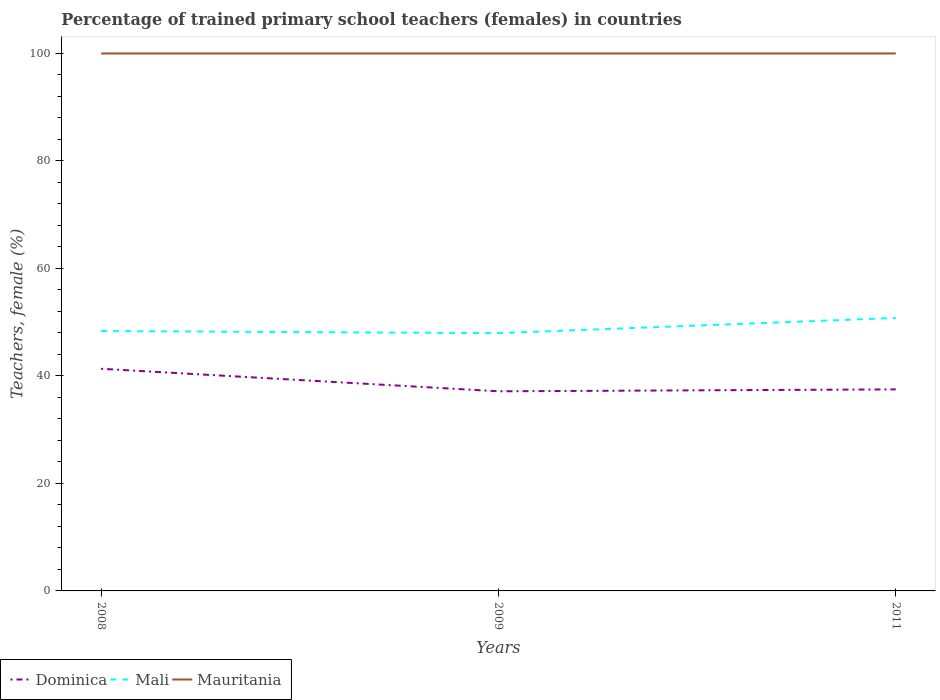Does the line corresponding to Dominica intersect with the line corresponding to Mauritania?
Offer a terse response. No. Across all years, what is the maximum percentage of trained primary school teachers (females) in Dominica?
Make the answer very short. 37.14. In which year was the percentage of trained primary school teachers (females) in Mauritania maximum?
Your answer should be compact. 2008. What is the total percentage of trained primary school teachers (females) in Dominica in the graph?
Provide a short and direct response. 3.83. What is the difference between the highest and the second highest percentage of trained primary school teachers (females) in Dominica?
Keep it short and to the point. 4.19. What is the difference between two consecutive major ticks on the Y-axis?
Keep it short and to the point. 20. Where does the legend appear in the graph?
Your answer should be very brief. Bottom left. How are the legend labels stacked?
Make the answer very short. Horizontal. What is the title of the graph?
Keep it short and to the point. Percentage of trained primary school teachers (females) in countries. Does "France" appear as one of the legend labels in the graph?
Make the answer very short. No. What is the label or title of the X-axis?
Provide a succinct answer. Years. What is the label or title of the Y-axis?
Offer a terse response. Teachers, female (%). What is the Teachers, female (%) of Dominica in 2008?
Make the answer very short. 41.33. What is the Teachers, female (%) in Mali in 2008?
Offer a very short reply. 48.36. What is the Teachers, female (%) of Dominica in 2009?
Keep it short and to the point. 37.14. What is the Teachers, female (%) of Mali in 2009?
Offer a terse response. 47.96. What is the Teachers, female (%) in Mauritania in 2009?
Your answer should be very brief. 100. What is the Teachers, female (%) of Dominica in 2011?
Make the answer very short. 37.5. What is the Teachers, female (%) of Mali in 2011?
Make the answer very short. 50.79. Across all years, what is the maximum Teachers, female (%) in Dominica?
Give a very brief answer. 41.33. Across all years, what is the maximum Teachers, female (%) in Mali?
Keep it short and to the point. 50.79. Across all years, what is the maximum Teachers, female (%) of Mauritania?
Your answer should be very brief. 100. Across all years, what is the minimum Teachers, female (%) in Dominica?
Provide a short and direct response. 37.14. Across all years, what is the minimum Teachers, female (%) in Mali?
Provide a succinct answer. 47.96. What is the total Teachers, female (%) in Dominica in the graph?
Make the answer very short. 115.98. What is the total Teachers, female (%) of Mali in the graph?
Provide a short and direct response. 147.11. What is the total Teachers, female (%) in Mauritania in the graph?
Ensure brevity in your answer.  300. What is the difference between the Teachers, female (%) of Dominica in 2008 and that in 2009?
Give a very brief answer. 4.19. What is the difference between the Teachers, female (%) of Mali in 2008 and that in 2009?
Give a very brief answer. 0.4. What is the difference between the Teachers, female (%) of Mauritania in 2008 and that in 2009?
Your answer should be very brief. 0. What is the difference between the Teachers, female (%) of Dominica in 2008 and that in 2011?
Your answer should be very brief. 3.83. What is the difference between the Teachers, female (%) in Mali in 2008 and that in 2011?
Provide a short and direct response. -2.44. What is the difference between the Teachers, female (%) in Dominica in 2009 and that in 2011?
Your answer should be very brief. -0.36. What is the difference between the Teachers, female (%) of Mali in 2009 and that in 2011?
Make the answer very short. -2.83. What is the difference between the Teachers, female (%) in Dominica in 2008 and the Teachers, female (%) in Mali in 2009?
Ensure brevity in your answer.  -6.63. What is the difference between the Teachers, female (%) in Dominica in 2008 and the Teachers, female (%) in Mauritania in 2009?
Offer a terse response. -58.67. What is the difference between the Teachers, female (%) in Mali in 2008 and the Teachers, female (%) in Mauritania in 2009?
Your answer should be very brief. -51.64. What is the difference between the Teachers, female (%) of Dominica in 2008 and the Teachers, female (%) of Mali in 2011?
Make the answer very short. -9.46. What is the difference between the Teachers, female (%) in Dominica in 2008 and the Teachers, female (%) in Mauritania in 2011?
Give a very brief answer. -58.67. What is the difference between the Teachers, female (%) in Mali in 2008 and the Teachers, female (%) in Mauritania in 2011?
Give a very brief answer. -51.64. What is the difference between the Teachers, female (%) in Dominica in 2009 and the Teachers, female (%) in Mali in 2011?
Offer a very short reply. -13.65. What is the difference between the Teachers, female (%) of Dominica in 2009 and the Teachers, female (%) of Mauritania in 2011?
Your response must be concise. -62.86. What is the difference between the Teachers, female (%) of Mali in 2009 and the Teachers, female (%) of Mauritania in 2011?
Provide a succinct answer. -52.04. What is the average Teachers, female (%) in Dominica per year?
Make the answer very short. 38.66. What is the average Teachers, female (%) in Mali per year?
Ensure brevity in your answer.  49.04. What is the average Teachers, female (%) of Mauritania per year?
Offer a very short reply. 100. In the year 2008, what is the difference between the Teachers, female (%) of Dominica and Teachers, female (%) of Mali?
Provide a succinct answer. -7.02. In the year 2008, what is the difference between the Teachers, female (%) of Dominica and Teachers, female (%) of Mauritania?
Your answer should be compact. -58.67. In the year 2008, what is the difference between the Teachers, female (%) in Mali and Teachers, female (%) in Mauritania?
Provide a succinct answer. -51.64. In the year 2009, what is the difference between the Teachers, female (%) of Dominica and Teachers, female (%) of Mali?
Give a very brief answer. -10.82. In the year 2009, what is the difference between the Teachers, female (%) of Dominica and Teachers, female (%) of Mauritania?
Make the answer very short. -62.86. In the year 2009, what is the difference between the Teachers, female (%) in Mali and Teachers, female (%) in Mauritania?
Your answer should be very brief. -52.04. In the year 2011, what is the difference between the Teachers, female (%) of Dominica and Teachers, female (%) of Mali?
Make the answer very short. -13.29. In the year 2011, what is the difference between the Teachers, female (%) of Dominica and Teachers, female (%) of Mauritania?
Provide a succinct answer. -62.5. In the year 2011, what is the difference between the Teachers, female (%) in Mali and Teachers, female (%) in Mauritania?
Give a very brief answer. -49.21. What is the ratio of the Teachers, female (%) in Dominica in 2008 to that in 2009?
Keep it short and to the point. 1.11. What is the ratio of the Teachers, female (%) of Mali in 2008 to that in 2009?
Provide a short and direct response. 1.01. What is the ratio of the Teachers, female (%) in Dominica in 2008 to that in 2011?
Make the answer very short. 1.1. What is the ratio of the Teachers, female (%) of Dominica in 2009 to that in 2011?
Offer a very short reply. 0.99. What is the ratio of the Teachers, female (%) in Mali in 2009 to that in 2011?
Make the answer very short. 0.94. What is the difference between the highest and the second highest Teachers, female (%) of Dominica?
Give a very brief answer. 3.83. What is the difference between the highest and the second highest Teachers, female (%) in Mali?
Ensure brevity in your answer.  2.44. What is the difference between the highest and the lowest Teachers, female (%) in Dominica?
Provide a short and direct response. 4.19. What is the difference between the highest and the lowest Teachers, female (%) in Mali?
Your response must be concise. 2.83. What is the difference between the highest and the lowest Teachers, female (%) of Mauritania?
Your answer should be compact. 0. 